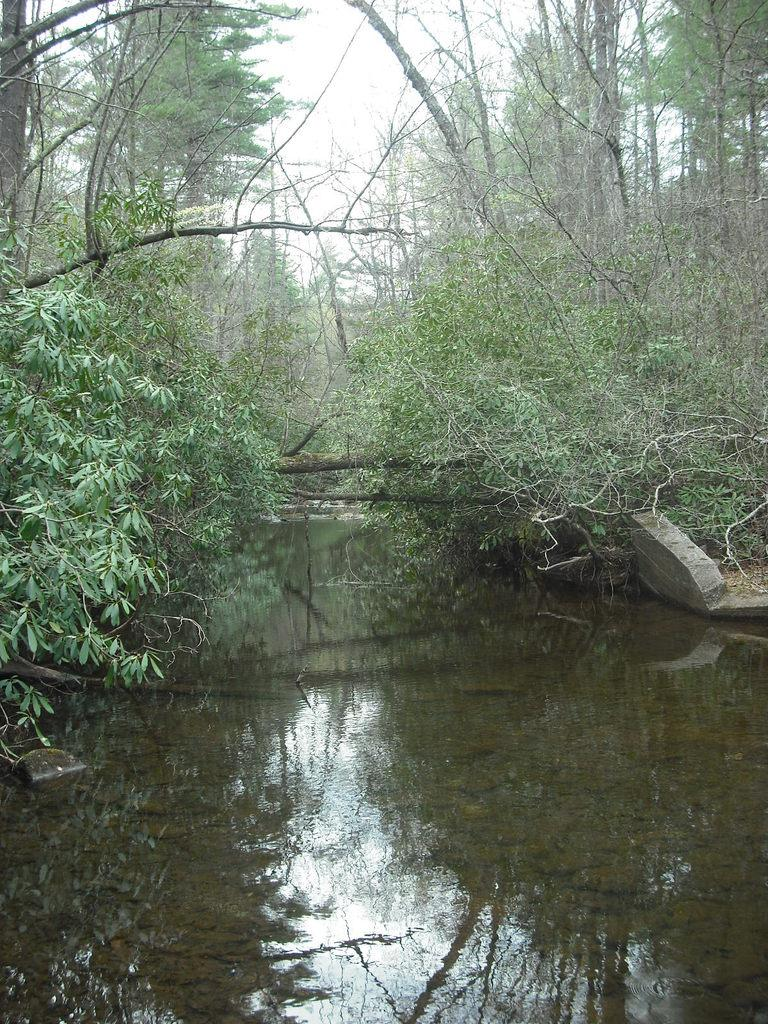What type of vegetation is present in the image? There are green color trees in the image. What natural element can be seen besides the trees in the image? There is water visible in the image. What part of the natural environment is visible in the image? The sky is visible in the image. What type of disease is affecting the trees in the image? There is no indication of any disease affecting the trees in the image; they appear to be healthy green trees. What type of pollution can be seen in the image? There is no pollution visible in the image; it features a natural scene with trees, water, and the sky. 